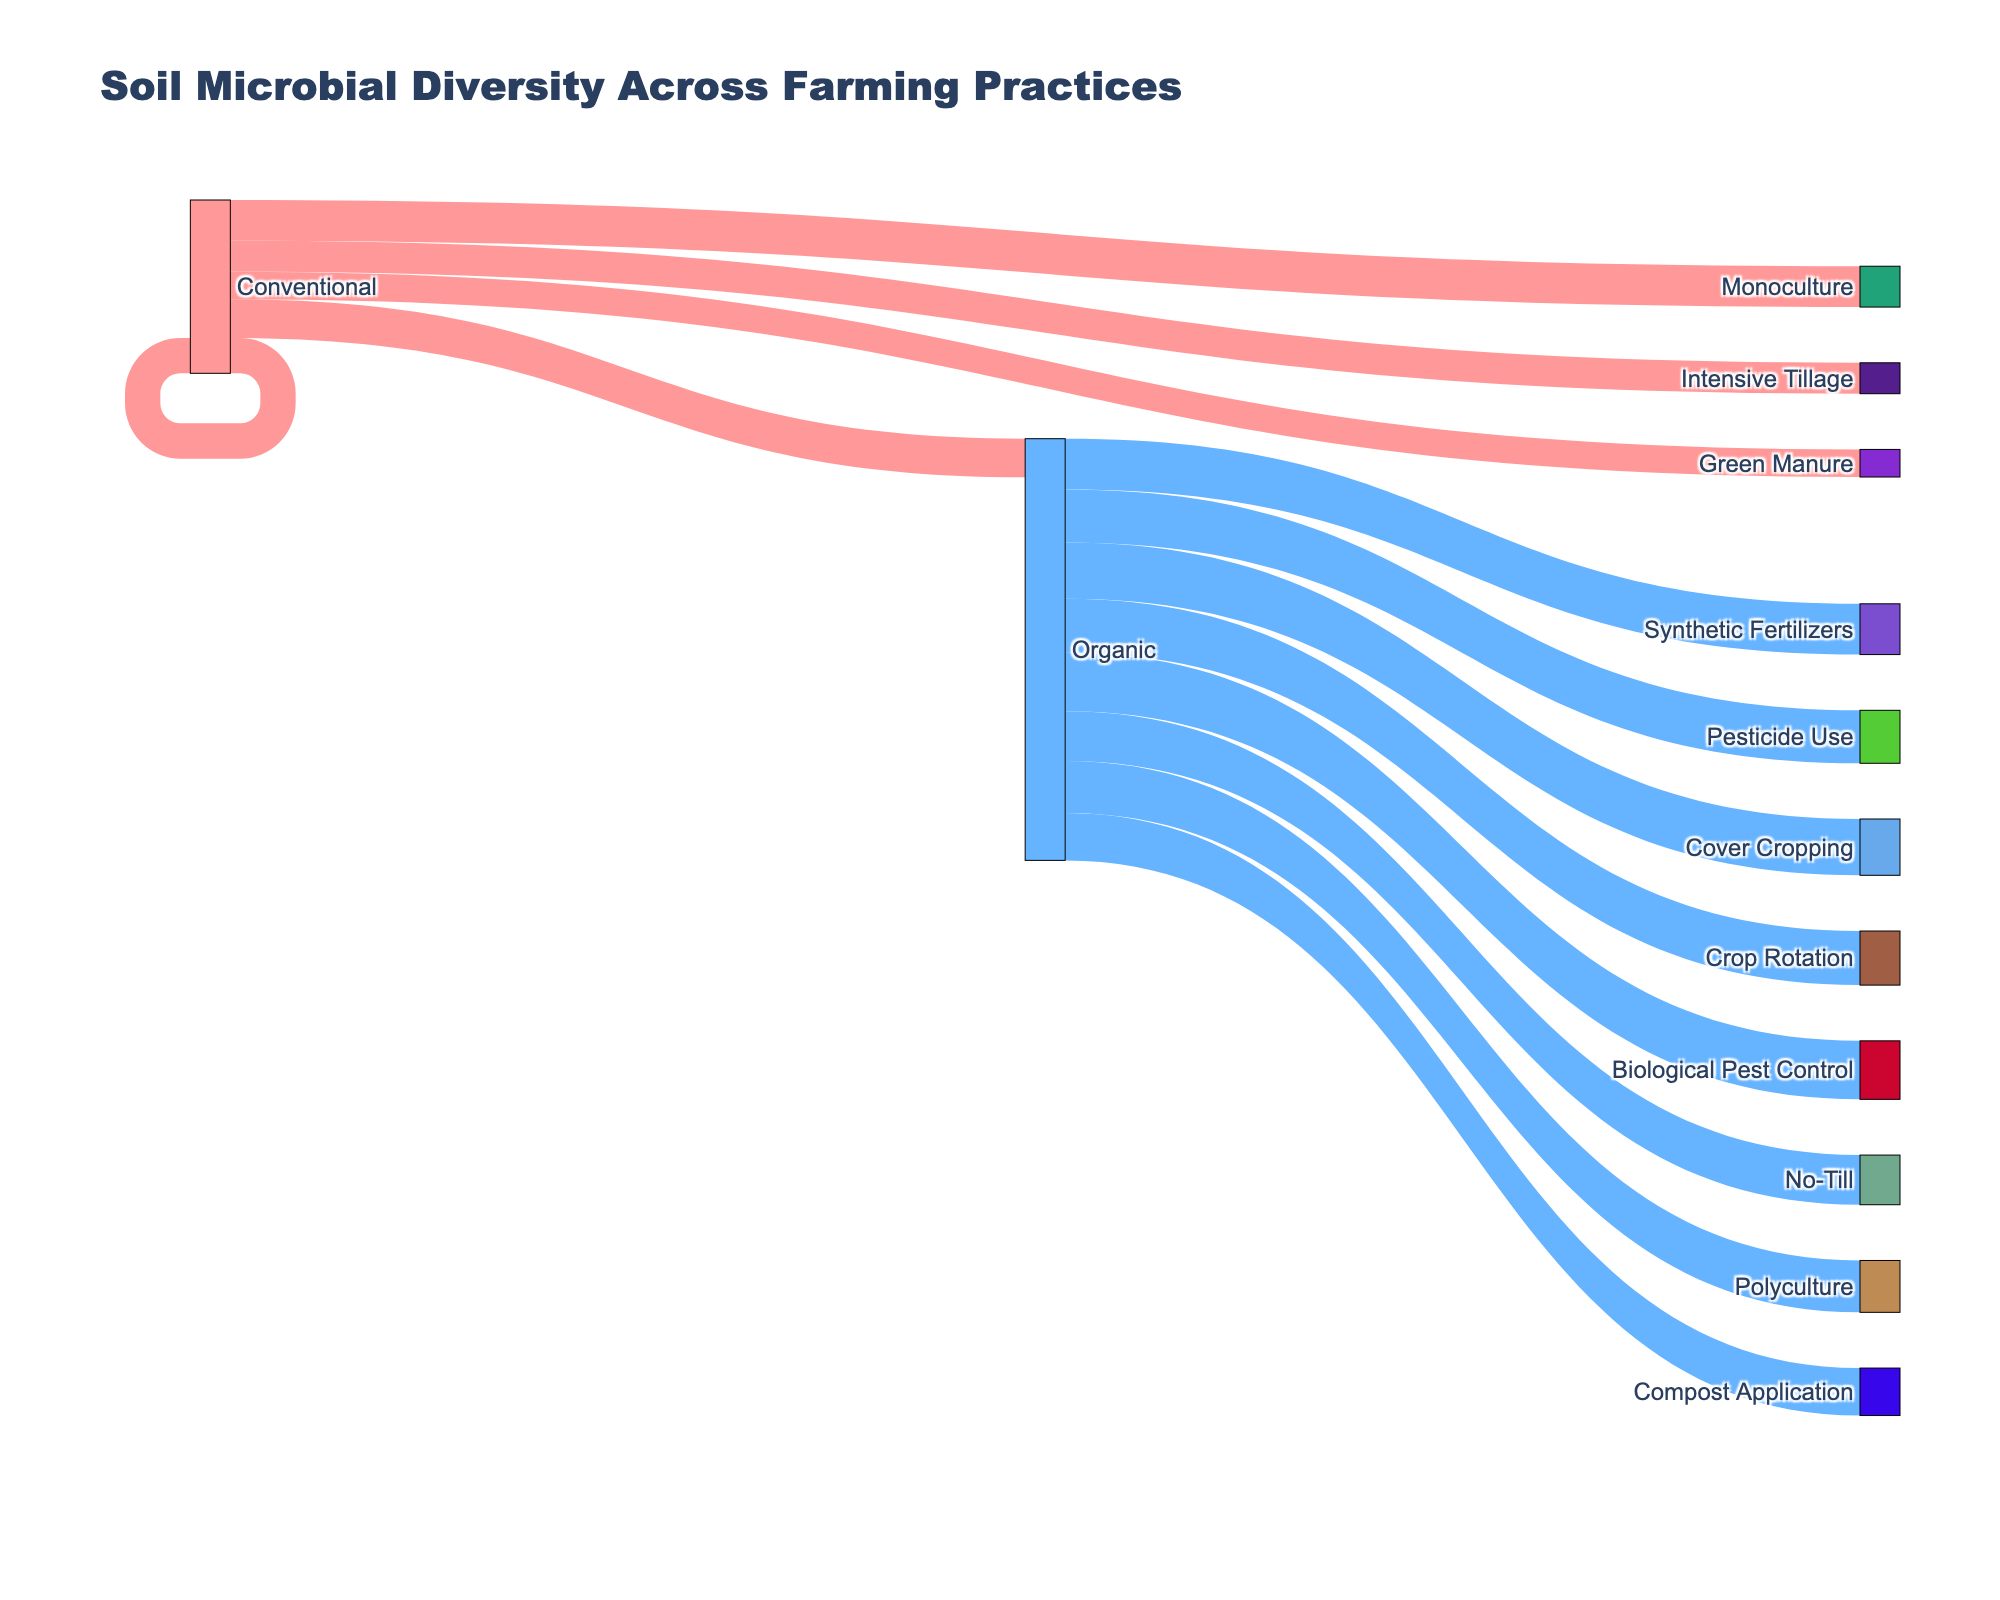What is the title of the figure? The title is displayed at the top of the figure. It reads "Soil Microbial Diversity Across Farming Practices".
Answer: Soil Microbial Diversity Across Farming Practices How many farming practices are compared in the figure? Identify the number of unique practices listed under both Conventional and Organic sources. There are 5 Conventional and 8 Organic practices.
Answer: 13 Which practice has the highest Microbial Diversity Index? Find the length or shading of the target nodes representing different practices. "Polyculture" under "Organic" has the highest value.
Answer: Polyculture What is the average Microbial Diversity Index of the Organic practices? Add all the indices for Organic practices and divide by the number of practices: (4.6 + 4.8 + 4.5 + 5.1 + 4.9 + 4.3 + 5.3 + 4.7) / 8 = 4.775.
Answer: 4.775 How does the microbial diversity of No-Till compare to Intensive Tillage? Compare the values associated with No-Till (4.6) and Intensive Tillage (3.2). No-Till has a higher value.
Answer: No-Till is higher What is the difference in the Microbial Diversity Index between the practice with the highest index and the practice with the lowest index? Compare the highest index (Polyculture, 5.3) and the lowest index (Monoculture, 2.5). Calculate the difference: 5.3 - 2.5 = 2.8.
Answer: 2.8 How many Organic practices have a Microbial Diversity Index greater than 4.5? Identify the Organic practices with indices above 4.5: No-Till, Cover Cropping, Compost Application, Green Manure, Polyculture, and Rainwater Harvesting. There are 6 such practices.
Answer: 6 Which Conventional practice has the lowest Microbial Diversity Index? Compare the values associated with each Conventional practice. Monoculture has the lowest value at 2.5.
Answer: Monoculture 